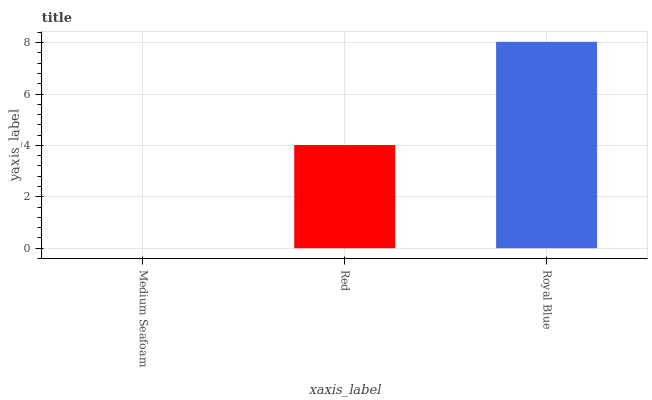Is Medium Seafoam the minimum?
Answer yes or no. Yes. Is Royal Blue the maximum?
Answer yes or no. Yes. Is Red the minimum?
Answer yes or no. No. Is Red the maximum?
Answer yes or no. No. Is Red greater than Medium Seafoam?
Answer yes or no. Yes. Is Medium Seafoam less than Red?
Answer yes or no. Yes. Is Medium Seafoam greater than Red?
Answer yes or no. No. Is Red less than Medium Seafoam?
Answer yes or no. No. Is Red the high median?
Answer yes or no. Yes. Is Red the low median?
Answer yes or no. Yes. Is Medium Seafoam the high median?
Answer yes or no. No. Is Royal Blue the low median?
Answer yes or no. No. 